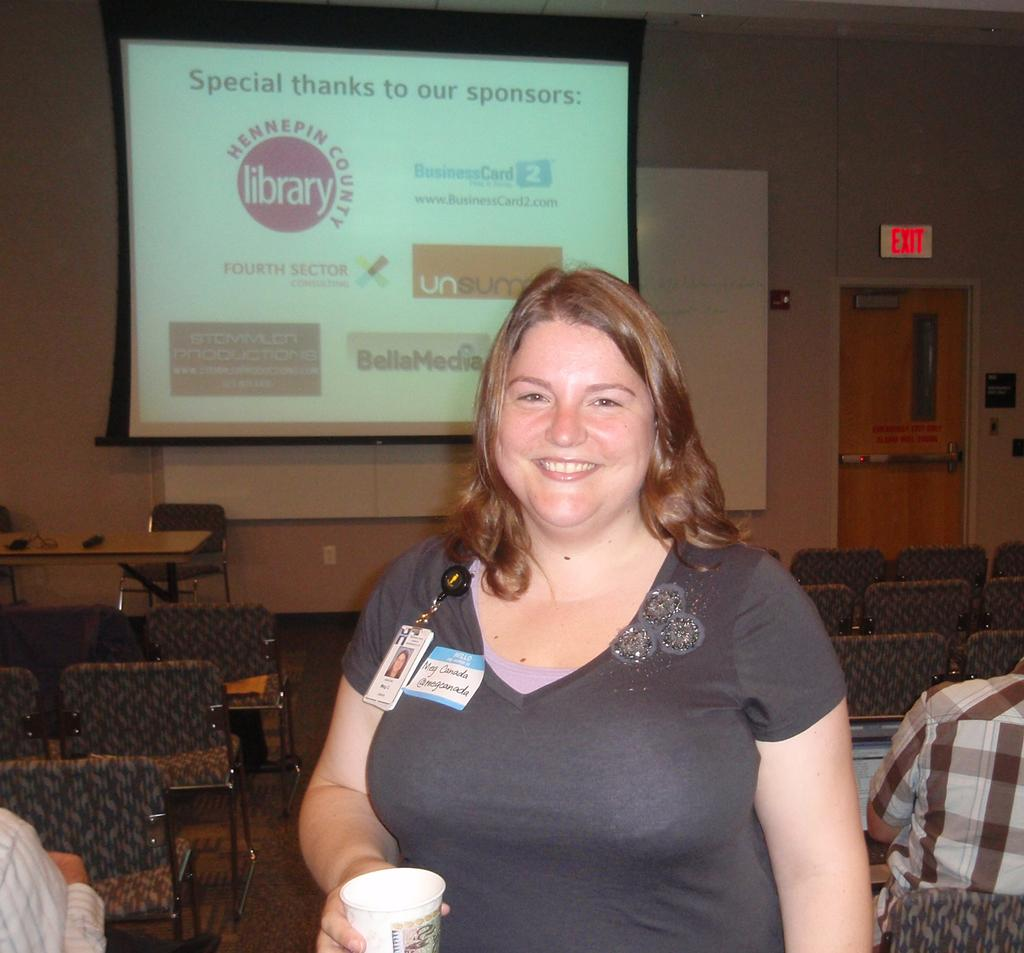Who is present in the image? There is a woman in the image. What is the woman holding in the image? The woman is holding a cup. What is the woman's facial expression in the image? The woman is smiling. What can be seen in the background of the image? There is a projector display and chairs in the background. What type of base is supporting the carpenter in the image? There is no carpenter or base present in the image. What event is taking place in the image? The image does not depict a specific event; it simply shows a woman holding a cup and smiling, with a projector display and chairs in the background. 